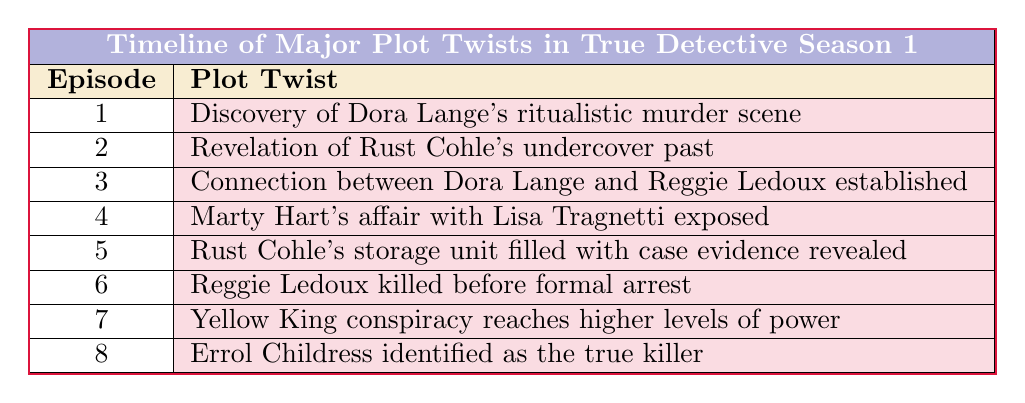What is the plot twist revealed in episode 3? According to the table, the plot twist in episode 3 is "Connection between Dora Lange and Reggie Ledoux established."
Answer: Connection between Dora Lange and Reggie Ledoux established How many plot twists occur before episode 5? The table lists plot twists for episodes 1 through 4, totaling four plot twists before episode 5.
Answer: Four plot twists Is there a plot twist related to Rust Cohle in episode 2? Yes, the table indicates that episode 2 features the plot twist "Revelation of Rust Cohle's undercover past." Therefore, this fact is true.
Answer: Yes What was the last plot twist mentioned in the table? The table states that the last plot twist occurs in episode 8, which is "Errol Childress identified as the true killer."
Answer: Errol Childress identified as the true killer Which episode reveals the most significant character flaw regarding Marty Hart? Episode 4 reveals that "Marty Hart's affair with Lisa Tragnetti exposed," highlighting a significant personal flaw.
Answer: Episode 4 How many episodes contain plot twists involving an arrest or related context? Episodes 6 ("Reggie Ledoux killed before formal arrest") and 5 ("Rust Cohle's storage unit filled with case evidence revealed") contain context regarding arrests, totaling two episodes.
Answer: Two episodes What is the connection between episode 3 and episode 7 in terms of the plot twist? Episode 3 establishes a connection between characters, while episode 7 reveals that "Yellow King conspiracy reaches higher levels of power," indicating that the events in episode 3 are related to the broader conspiracy discussed in episode 7.
Answer: Both episodes are interconnected through the unfolding conspiracy How does the plot twist in episode 6 affect the investigation's direction? The twist in episode 6 regarding the death of Reggie Ledoux significantly impacts the investigation's direction by eliminating a primary suspect before a formal arrest could take place, making the detectives reconsider their leads.
Answer: It shifts the investigation Which plot twist aligns with episode 7's exploration of power dynamics? Episode 7's twist about the "Yellow King conspiracy reaches higher levels of power" aligns with the overarching theme of corruption and power seen in earlier episodes, particularly with the establishment from episode 3's connection.
Answer: The twist about the Yellow King conspiracy 